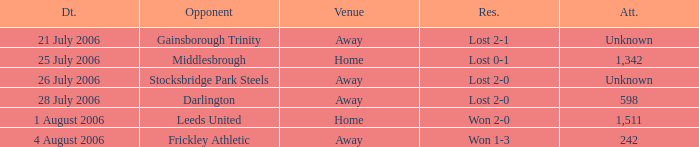Which opponent has unknown attendance, and lost 2-0? Stocksbridge Park Steels. Can you parse all the data within this table? {'header': ['Dt.', 'Opponent', 'Venue', 'Res.', 'Att.'], 'rows': [['21 July 2006', 'Gainsborough Trinity', 'Away', 'Lost 2-1', 'Unknown'], ['25 July 2006', 'Middlesbrough', 'Home', 'Lost 0-1', '1,342'], ['26 July 2006', 'Stocksbridge Park Steels', 'Away', 'Lost 2-0', 'Unknown'], ['28 July 2006', 'Darlington', 'Away', 'Lost 2-0', '598'], ['1 August 2006', 'Leeds United', 'Home', 'Won 2-0', '1,511'], ['4 August 2006', 'Frickley Athletic', 'Away', 'Won 1-3', '242']]} 